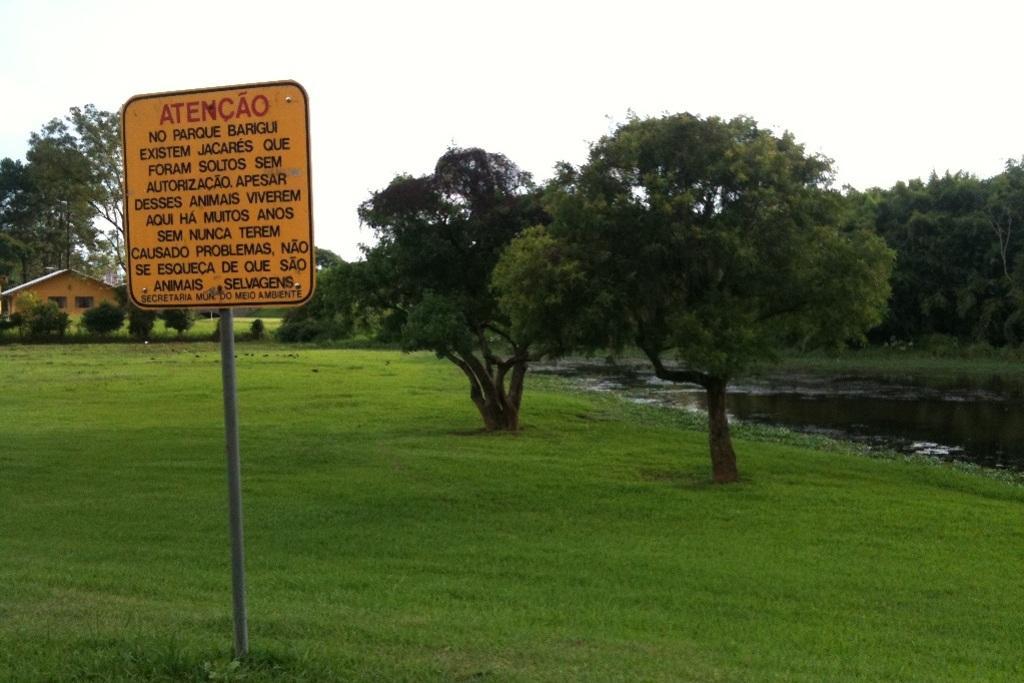Please provide a concise description of this image. On the left side of the image we can see one sign board. On the sign board, we can see some text. In the background, we can see the sky, trees, one house, grass and water. 